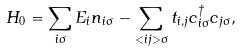<formula> <loc_0><loc_0><loc_500><loc_500>H _ { 0 } = \sum _ { i \sigma } E _ { i } n _ { i \sigma } - \sum _ { < i j > \sigma } t _ { i , j } c _ { i \sigma } ^ { \dagger } c _ { j \sigma } , \\</formula> 